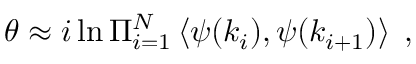Convert formula to latex. <formula><loc_0><loc_0><loc_500><loc_500>\theta \approx i \ln \Pi _ { i = 1 } ^ { N } \left < \psi ( k _ { i } ) , \psi ( k _ { i + 1 } ) \right > \, ,</formula> 